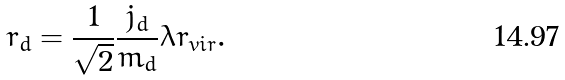<formula> <loc_0><loc_0><loc_500><loc_500>r _ { d } = \frac { 1 } { \sqrt { 2 } } \frac { j _ { d } } { m _ { d } } \lambda r _ { v i r } .</formula> 